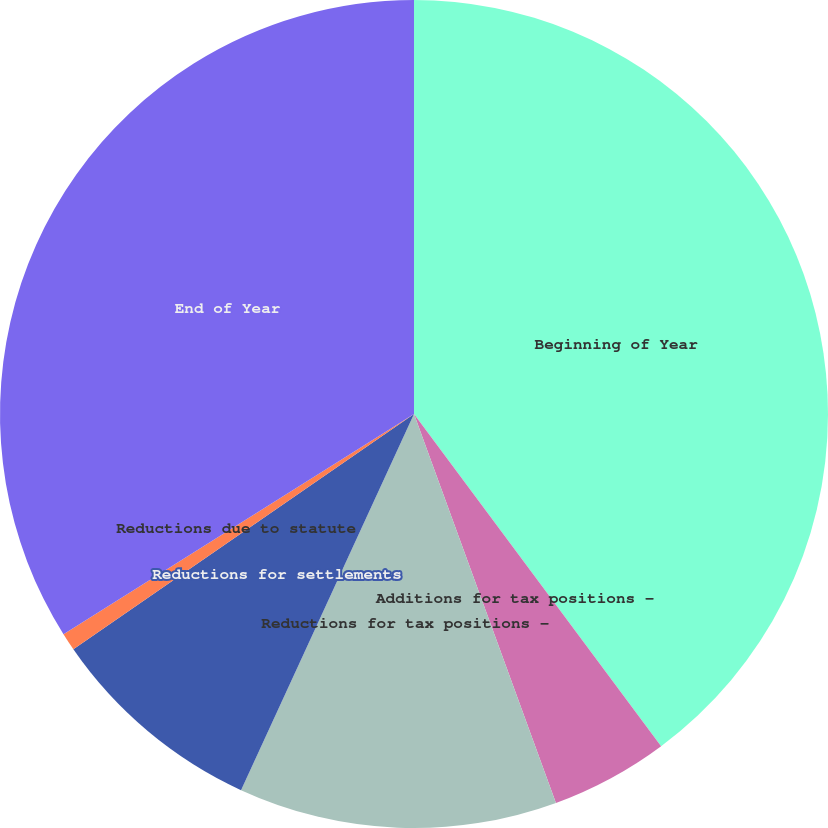Convert chart to OTSL. <chart><loc_0><loc_0><loc_500><loc_500><pie_chart><fcel>Beginning of Year<fcel>Additions for tax positions -<fcel>Reductions for tax positions -<fcel>Reductions for settlements<fcel>Reductions due to statute<fcel>End of Year<nl><fcel>39.82%<fcel>4.61%<fcel>12.43%<fcel>8.52%<fcel>0.69%<fcel>33.93%<nl></chart> 